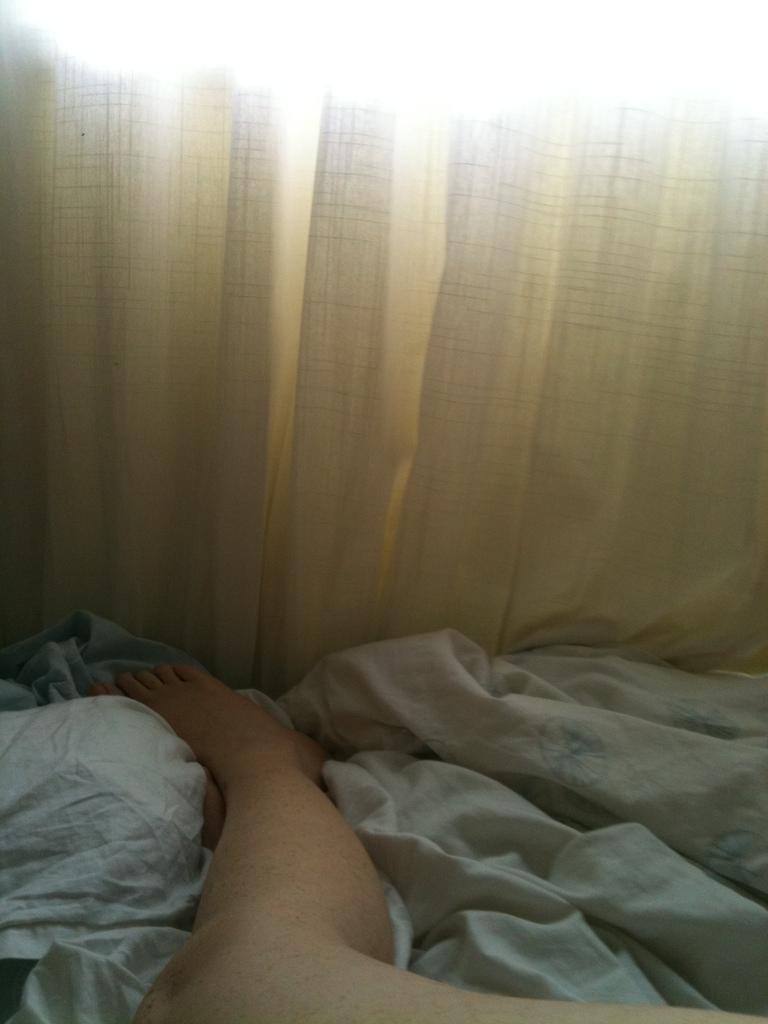Please provide a concise description of this image. In this image we can see the legs of a person and a blanket. On the backside we can see a curtain. 